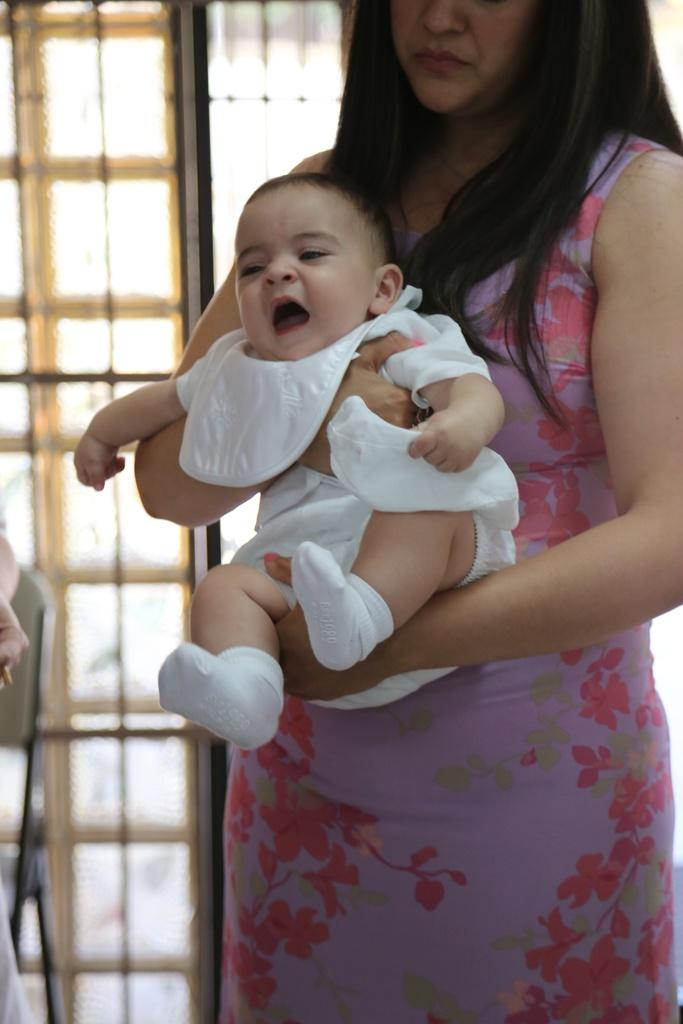What is the woman in the image doing? The woman is standing in the image and holding a baby. Can you describe the baby in the image? The baby is being held by the woman. What can be seen in the background of the image? The background of the image is blurry, but there is a chair and a glass visible. What might the woman be sitting on if the chair is in the background? The woman might be standing or using another piece of furniture, as the chair is in the background. What type of sack is the woman using to carry the baby in the image? There is no sack present in the image; the woman is holding the baby directly. How does the room look in the image? The image does not show a room; it is focused on the woman and the baby, with a blurry background. 